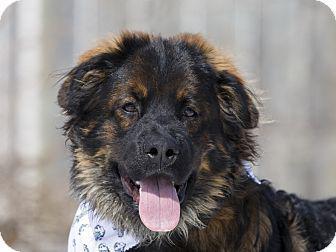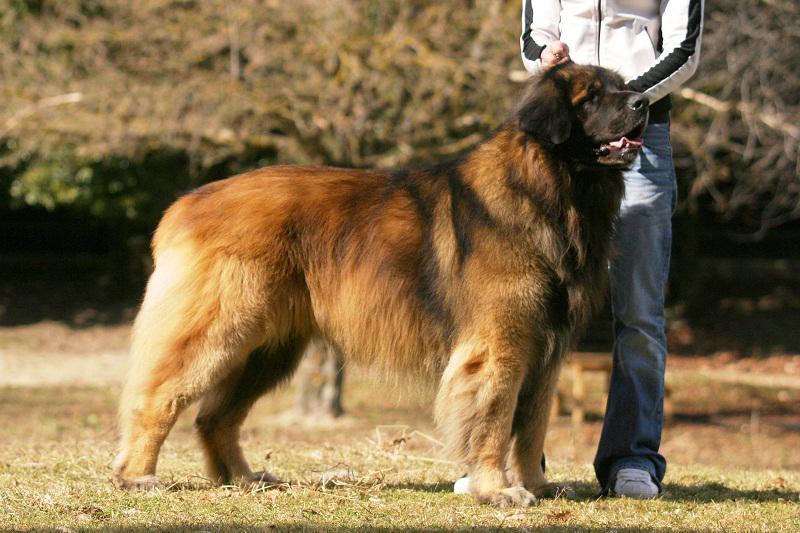The first image is the image on the left, the second image is the image on the right. Analyze the images presented: Is the assertion "One photo is a closeup of a dog's head and shoulders." valid? Answer yes or no. Yes. The first image is the image on the left, the second image is the image on the right. Given the left and right images, does the statement "The dog in the image on the right is standing outside alone." hold true? Answer yes or no. No. The first image is the image on the left, the second image is the image on the right. Considering the images on both sides, is "A dog with its face turned rightward is standing still on the grass in one image." valid? Answer yes or no. Yes. The first image is the image on the left, the second image is the image on the right. Evaluate the accuracy of this statement regarding the images: "In one image you can only see the dogs head.". Is it true? Answer yes or no. Yes. 